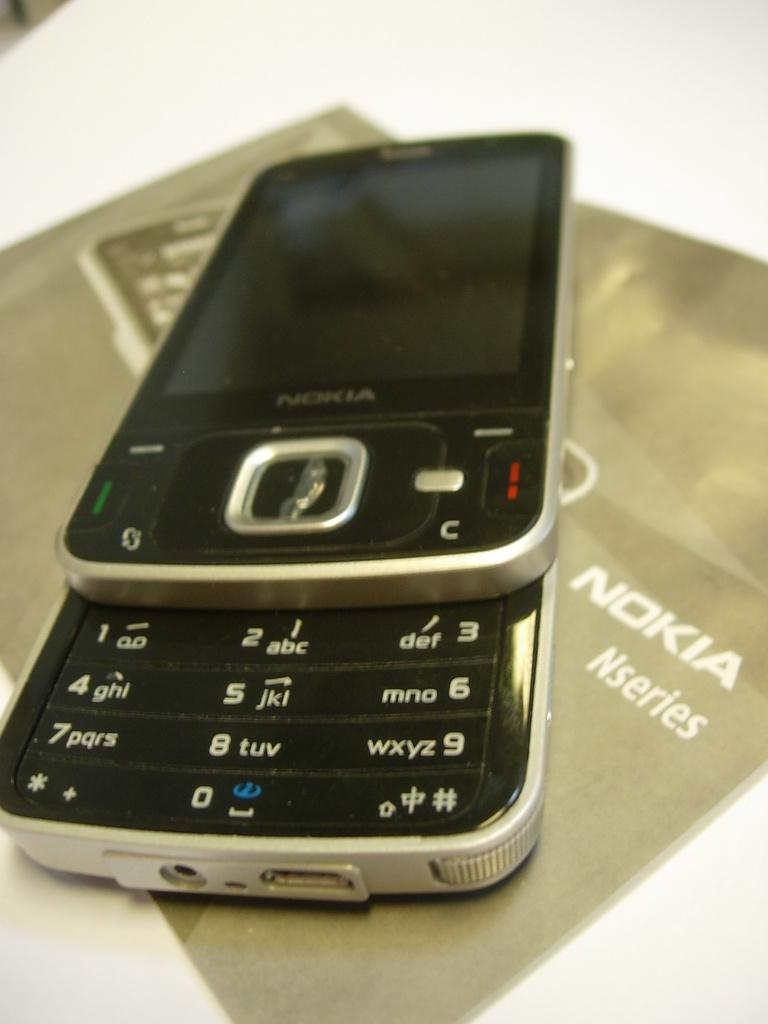<image>
Give a short and clear explanation of the subsequent image. The small Nokia N series phone slides open to dial. 